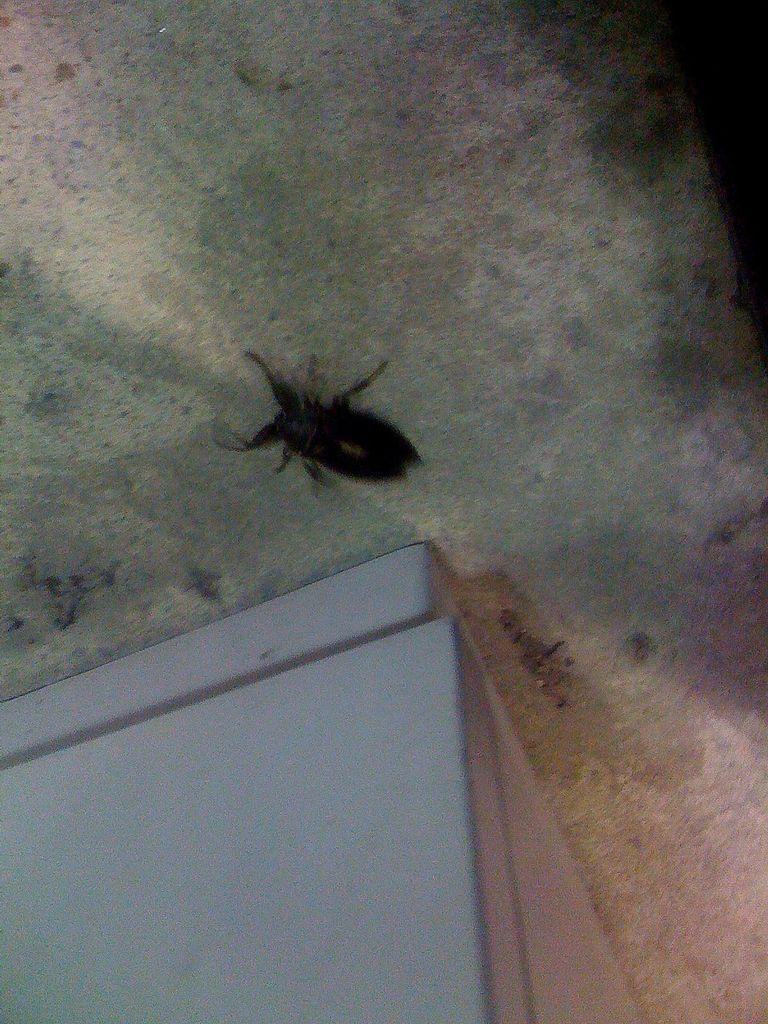Describe this image in one or two sentences. In this picture we can see an insect and a white object. 